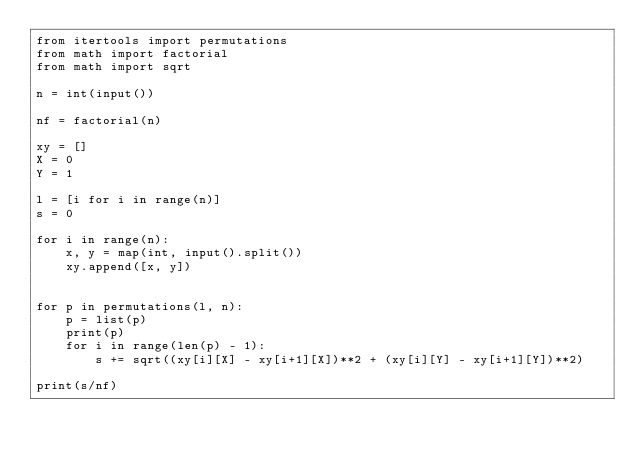<code> <loc_0><loc_0><loc_500><loc_500><_Python_>from itertools import permutations
from math import factorial
from math import sqrt

n = int(input())

nf = factorial(n)

xy = []
X = 0
Y = 1

l = [i for i in range(n)]
s = 0

for i in range(n):
    x, y = map(int, input().split())
    xy.append([x, y])


for p in permutations(l, n):
    p = list(p)
    print(p)
    for i in range(len(p) - 1):
        s += sqrt((xy[i][X] - xy[i+1][X])**2 + (xy[i][Y] - xy[i+1][Y])**2)

print(s/nf)
</code> 